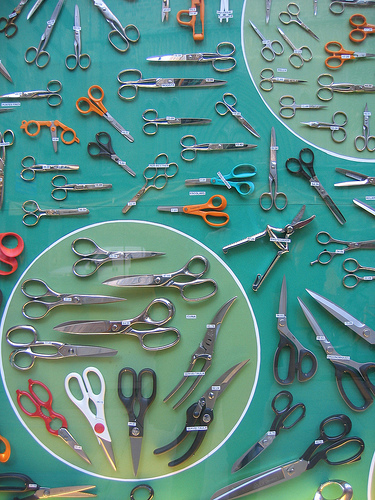Can you describe the overall theme of the image? The image features a colorful assortment of scissors neatly arranged on a blue mat. The scissors vary in size, shape, and color, creating a visually appealing and organized display. This theme highlights the diversity and utility of scissors as tools. How many pairs of orange scissors can you spot? There are three pairs of orange scissors visible in the image. 